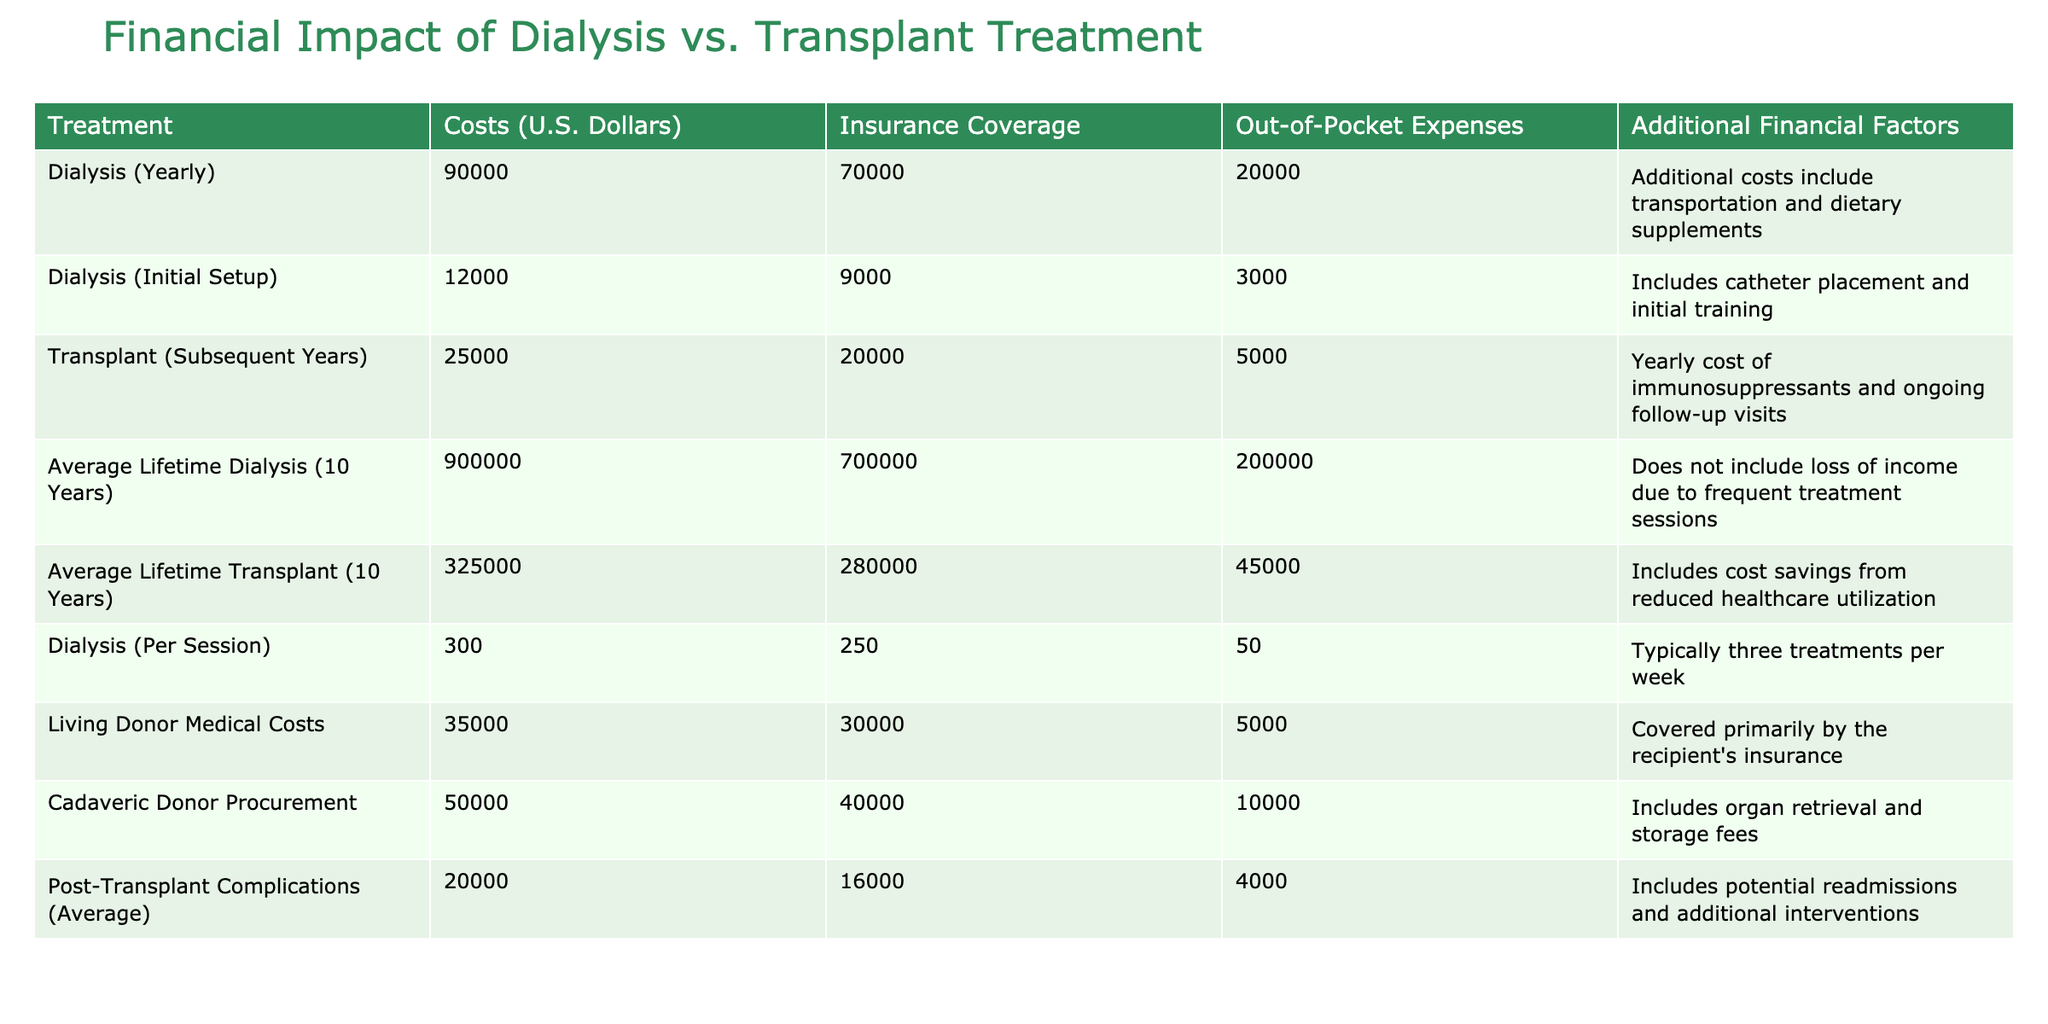What is the yearly cost of dialysis? The table specifies that the yearly cost of dialysis is listed directly under the "Costs (U.S. Dollars)" column for dialysis (yearly), which shows a value of 90,000.
Answer: 90,000 What are the out-of-pocket expenses for a transplant over ten years? The out-of-pocket expenses for an average lifetime transplant (10 years) are stated in the table as 45,000, found in the corresponding row for the transplant treatment.
Answer: 45,000 Is the insurance coverage for dialysis sessions greater than that for transplant? The insurance coverage for dialysis (per session) is listed as 250, while the coverage for transplant (subsequent years) is 20,000. Since 250 is less than 20,000, the statement is false.
Answer: No What is the total average lifetime cost of dialysis over ten years? The table indicates that the average lifetime cost of dialysis (10 years) is 900,000 as directly provided in the data.
Answer: 900,000 How much more do out-of-pocket expenses for dialysis (yearly) compare to transplant (subsequent years)? To find this, we look at the out-of-pocket expenses for both treatments: dialysis (yearly) is 20,000 and transplant (subsequent years) is 5,000. The difference is calculated as 20,000 - 5,000 = 15,000.
Answer: 15,000 What percentage of the total average lifetime cost of transplant is covered by insurance? The table shows that the average lifetime cost of transplant is 325,000 and the insurance coverage for it is 280,000. The percentage can be calculated as (280,000 / 325,000) * 100 = 86.15%.
Answer: 86.15% Are additional financial factors included in the average lifetime costs? The average lifetime cost entries in the table note additional financial factors under the related column. Therefore, the answer is yes.
Answer: Yes What are the initial setup costs for dialysis, including both insurance and out-of-pocket expenses? The initial setup cost for dialysis is listed as 12,000, with insurance coverage of 9,000 and out-of-pocket costs of 3,000. Adding these together: 12,000 + 9,000 + 3,000 = 24,000.
Answer: 24,000 If a patient has post-transplant complications, what might be the additional average costs? The average costs for post-transplant complications are specifically mentioned in the table as 20,000.
Answer: 20,000 